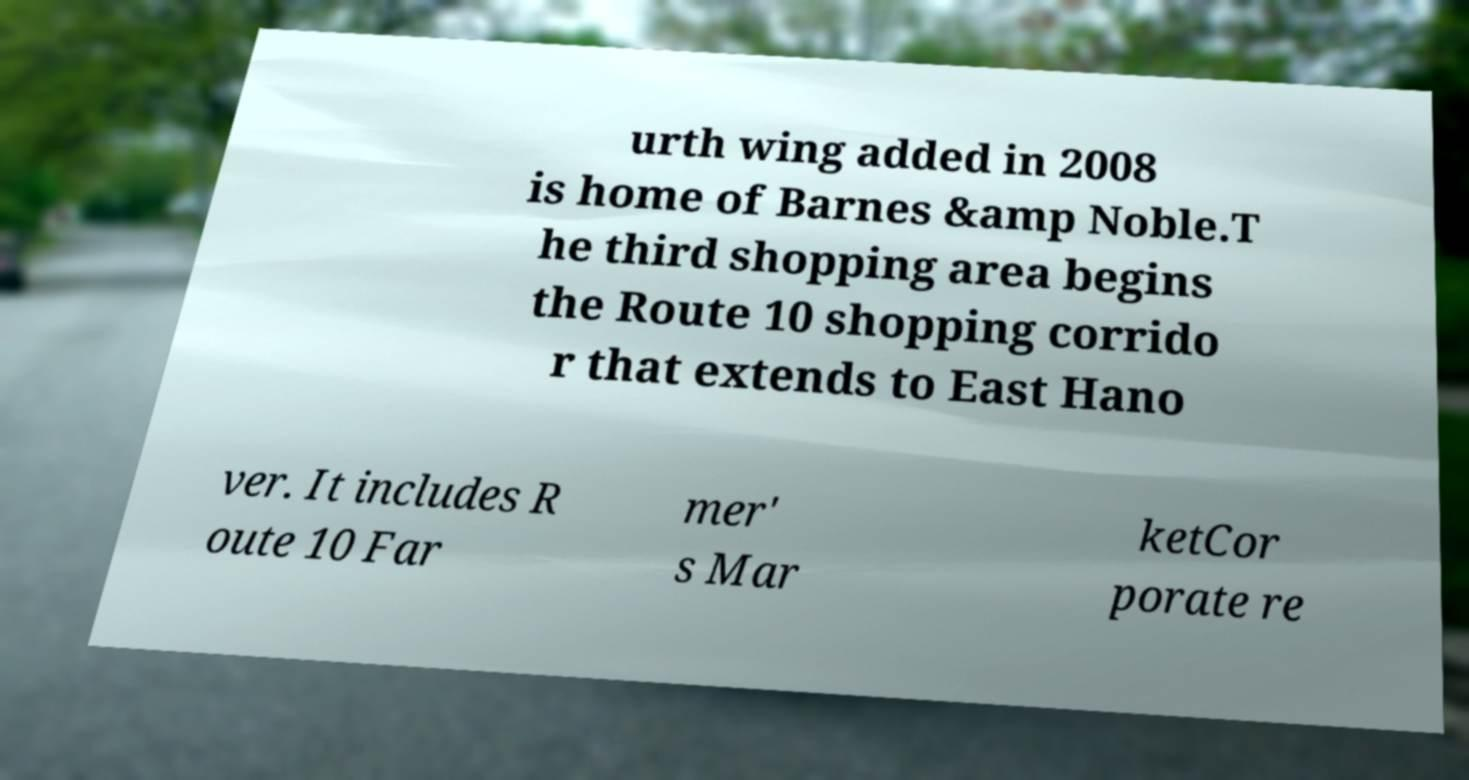Can you accurately transcribe the text from the provided image for me? urth wing added in 2008 is home of Barnes &amp Noble.T he third shopping area begins the Route 10 shopping corrido r that extends to East Hano ver. It includes R oute 10 Far mer' s Mar ketCor porate re 